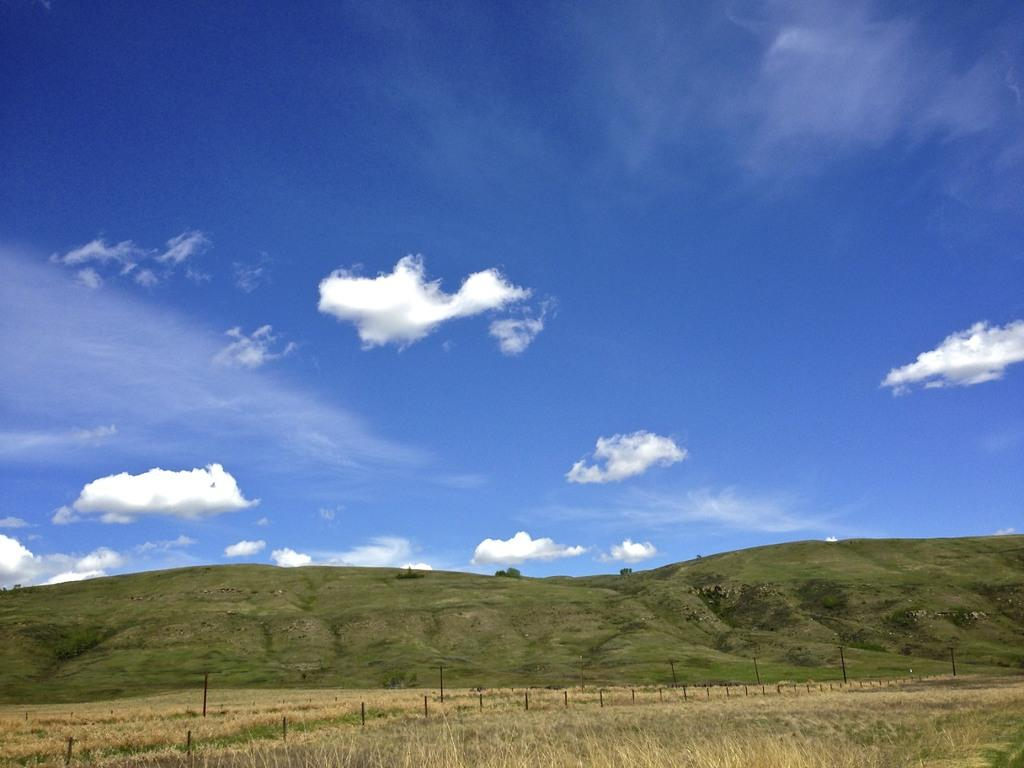What type of landscape is depicted in the image? The image features hills. What type of vegetation can be seen at the bottom of the hills? There is grass at the bottom of the image. What can be seen in the sky in the image? There are clouds in the sky. How many sponges are visible on the hills in the image? There are no sponges visible in the image; it features hills, grass, and clouds. Can you see any knots tied on the grass in the image? There are no knots visible in the image; it features hills, grass, and clouds. 